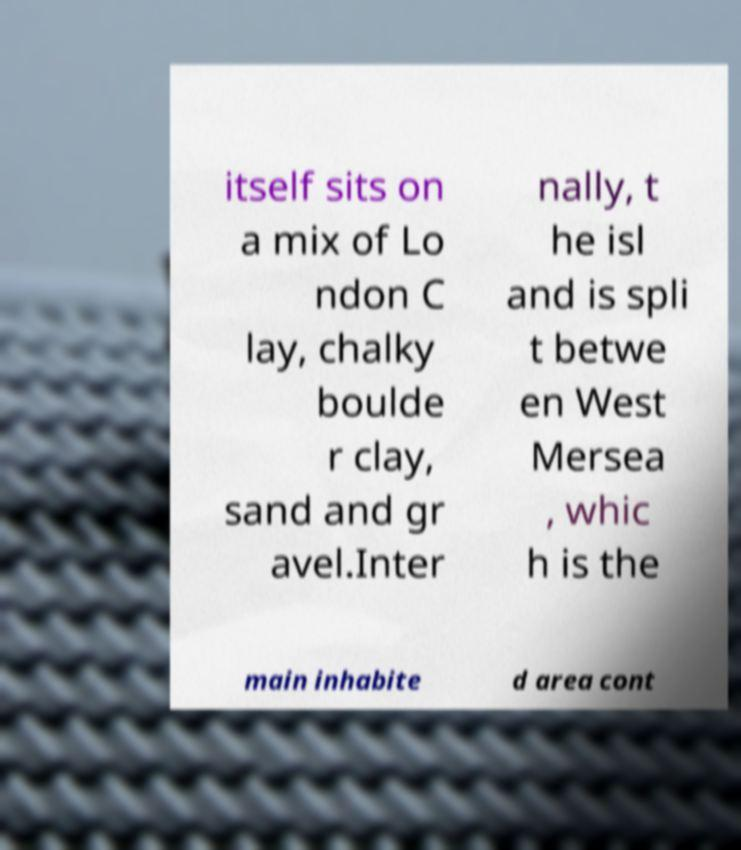Please read and relay the text visible in this image. What does it say? itself sits on a mix of Lo ndon C lay, chalky boulde r clay, sand and gr avel.Inter nally, t he isl and is spli t betwe en West Mersea , whic h is the main inhabite d area cont 